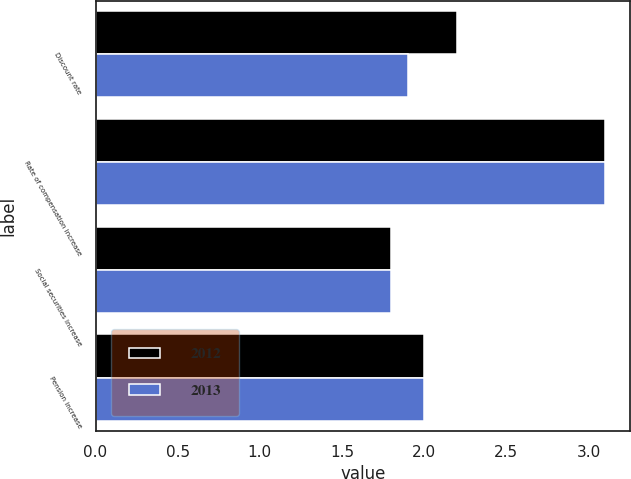<chart> <loc_0><loc_0><loc_500><loc_500><stacked_bar_chart><ecel><fcel>Discount rate<fcel>Rate of compensation increase<fcel>Social securities increase<fcel>Pension increase<nl><fcel>2012<fcel>2.2<fcel>3.1<fcel>1.8<fcel>2<nl><fcel>2013<fcel>1.9<fcel>3.1<fcel>1.8<fcel>2<nl></chart> 